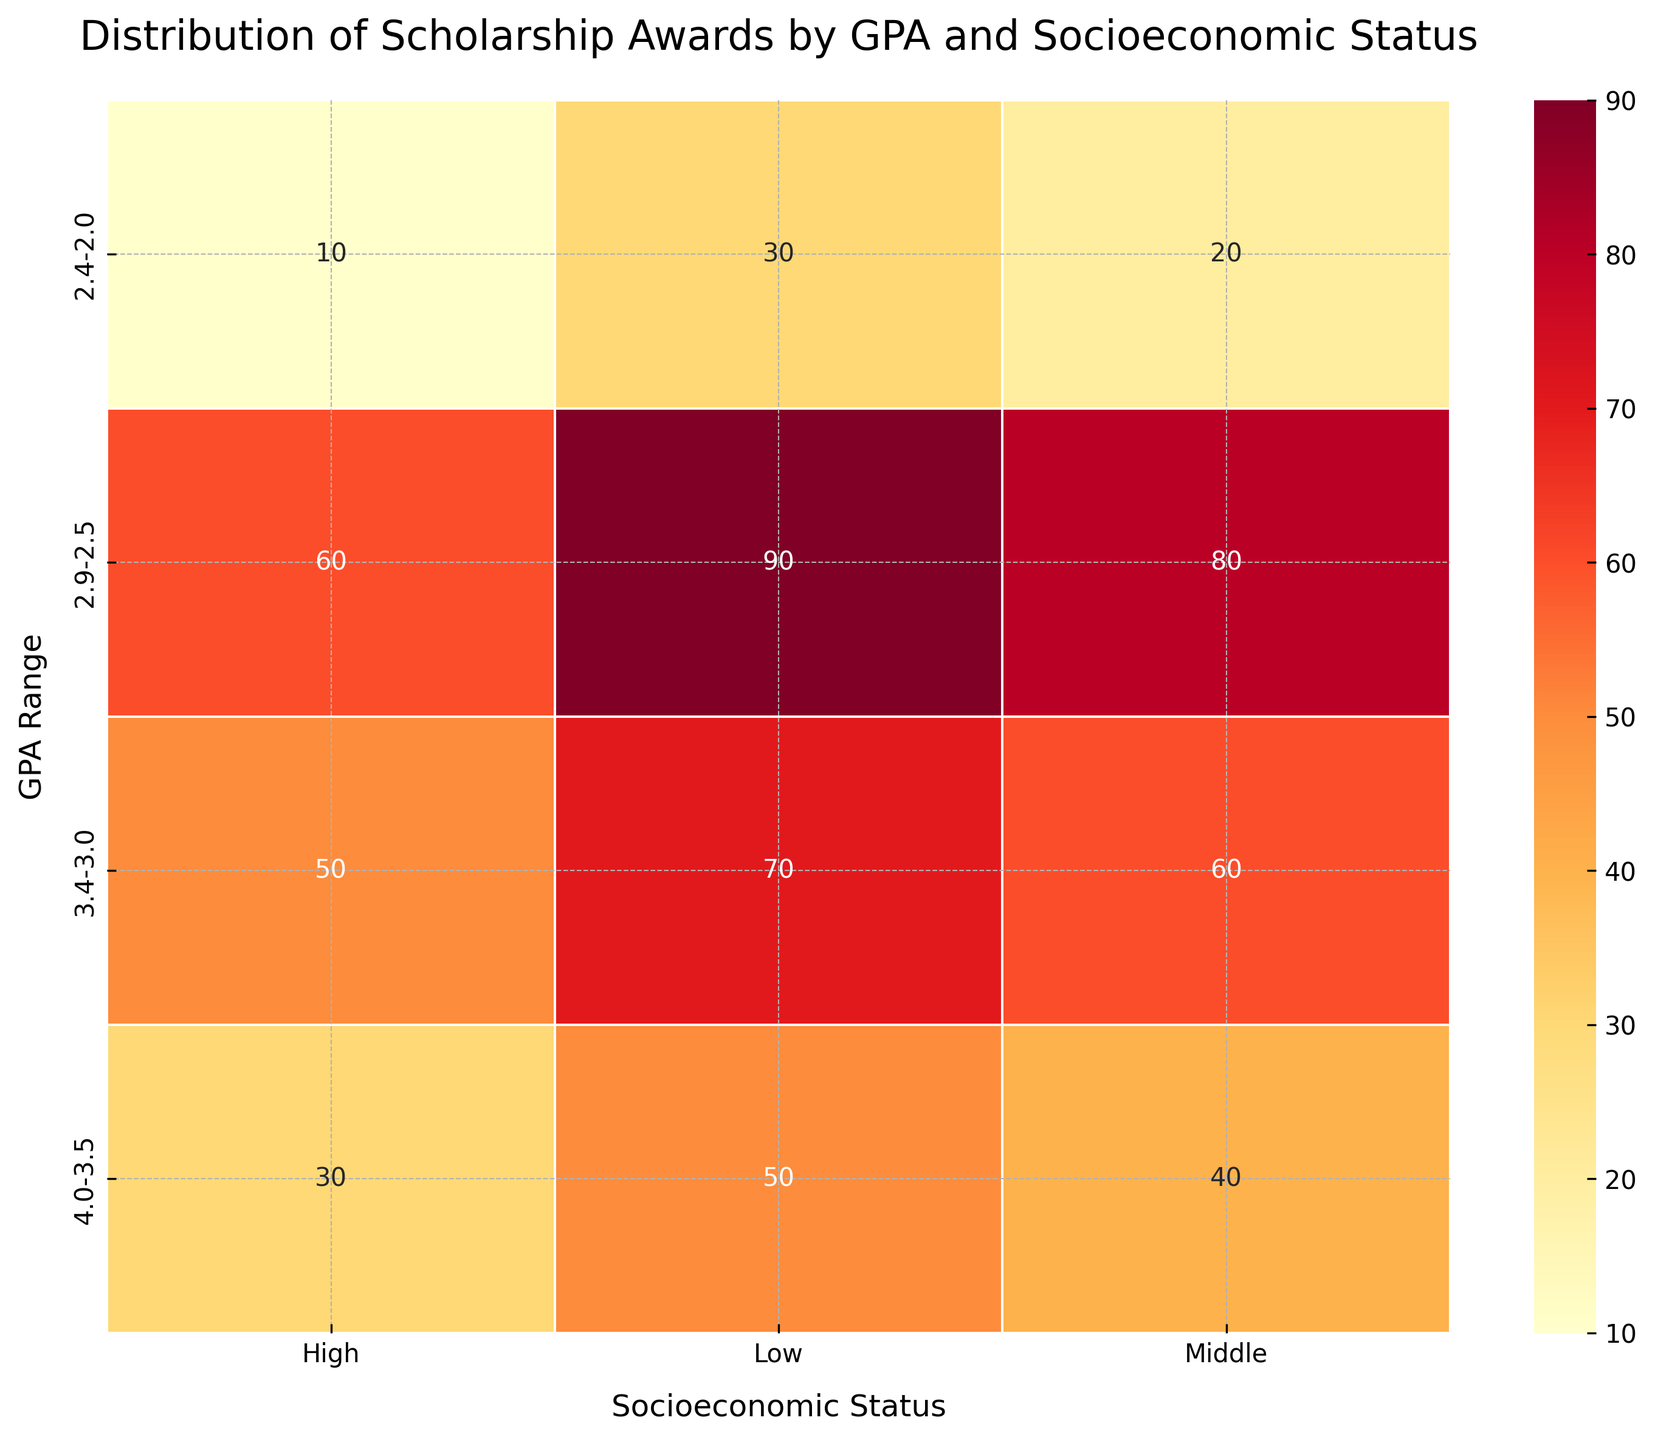What is the title of the heatmap? To find the title of the heatmap, look at the text usually positioned at the top of the figure. The title often describes the content or purpose of the plot.
Answer: Distribution of Scholarship Awards by GPA and Socioeconomic Status How many GPA ranges are represented in the heatmap? To determine the number of GPA ranges, look at the y-axis labels of the heatmap. Each label represents a unique GPA range.
Answer: 4 Which socioeconomic status has the highest number of scholarships awarded in the GPA range 2.9-2.5? To find the socioeconomic status with the highest number of scholarships in a specific GPA range, locate the GPA range on the y-axis and compare the annotated values in that row.
Answer: Low What is the total number of scholarships awarded in the GPA range 3.4-3.0? Calculate the total number of scholarships by summing the annotated values corresponding to the 3.4-3.0 GPA range across all socioeconomic statuses. 70 (Low) + 60 (Middle) + 50 (High) = 180
Answer: 180 How does the number of scholarships awarded to students with a GPA range of 4.0-3.5 compare between Low and High socioeconomic statuses? Compare the annotated numbers in the 4.0-3.5 GPA row for Low and High socioeconomic statuses. 50 (Low) vs 30 (High).
Answer: Low has 20 more scholarships than High What is the difference in the number of scholarships awarded between the highest and lowest socioeconomic statuses for students in the GPA range 3.4-3.0? To find the difference, subtract the number of scholarships awarded to the Low socioeconomic status from the number awarded to the High socioeconomic status in the same GPA range. 70 (Low) - 50 (High) = 20
Answer: 20 Which combination of GPA range and socioeconomic status received the least number of scholarships? Identify the lowest annotated number across the entire heatmap and determine the corresponding GPA range and socioeconomic status.
Answer: 2.4-2.0 GPA range and High socioeconomic status What is the average number of scholarships awarded to students with Middle socioeconomic status? Calculate the average by summing the number of scholarships awarded to Middle socioeconomic status across all GPA ranges and then dividing by the number of GPA ranges. (40 + 60 + 80 + 20) / 4 = 200 / 4 = 50
Answer: 50 Which GPA range saw the most scholarships awarded to Low socioeconomic status? Identify the GPA range row under the Low socioeconomic status column with the highest annotated number.
Answer: 2.9-2.5 